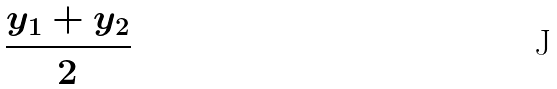<formula> <loc_0><loc_0><loc_500><loc_500>\frac { y _ { 1 } + y _ { 2 } } { 2 }</formula> 